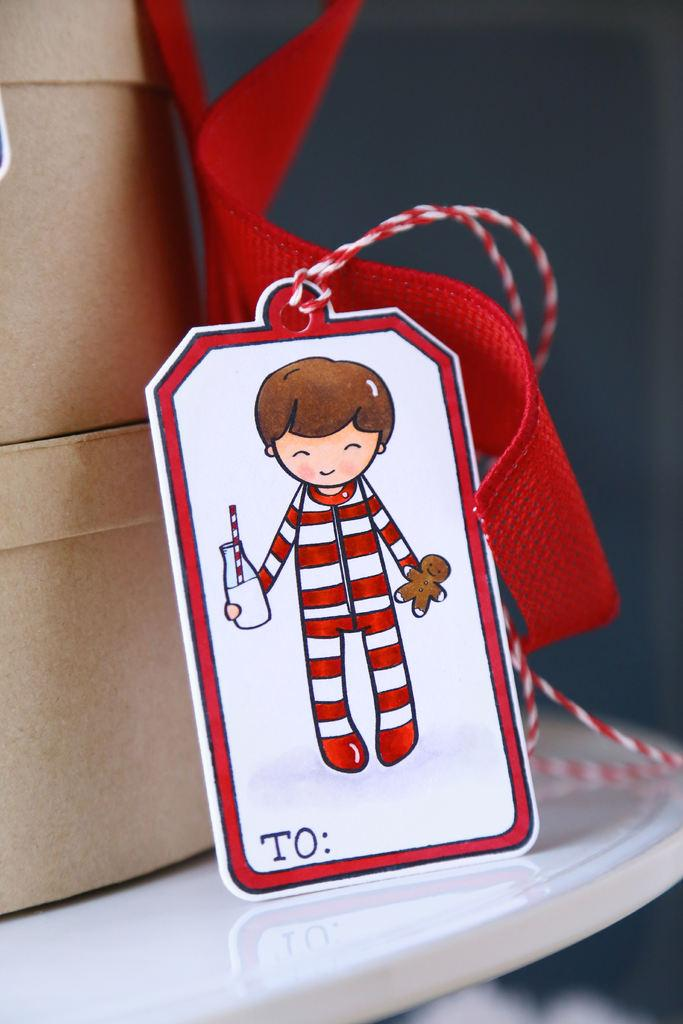What is the main piece of furniture in the image? There is a table in the image. What objects are on the table? There are two cardboard boxes on the table. What decorative or functional item can be seen in the image? There is a ribbon in the image. What type of label or identifier is present in the image? There is a tag in the image. What can be seen in the background of the image? There is a wall in the background of the image. Is there a spade being used to fight in the image? There is no spade or fighting depicted in the image. Are any characters wearing masks in the image? There are no characters or masks present in the image. 